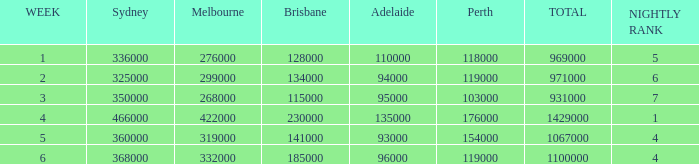What was the rating for Brisbane the week that Adelaide had 94000? 134000.0. 